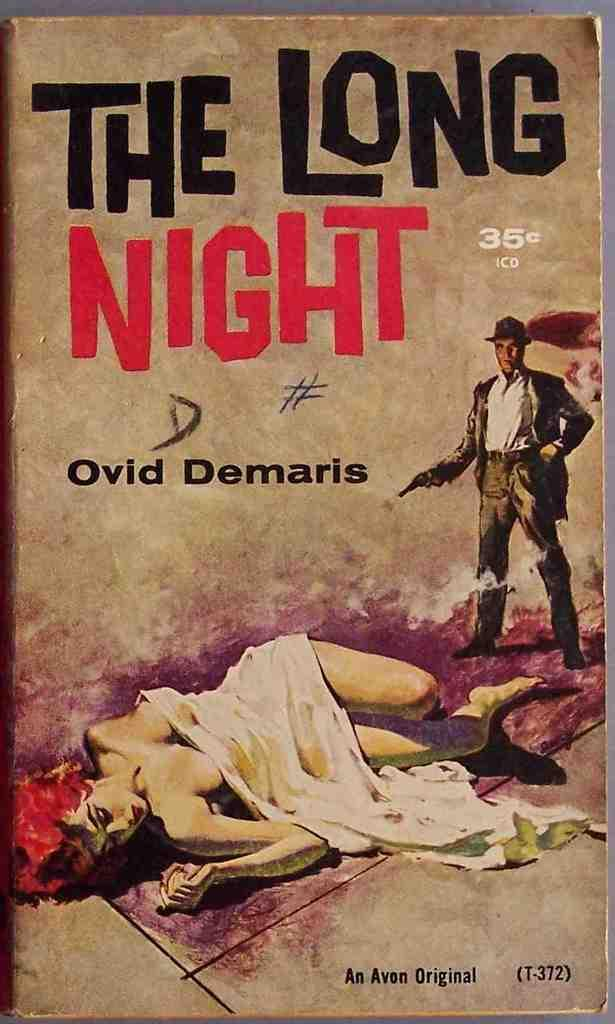Provide a one-sentence caption for the provided image. A picture of a book titled the long night. 